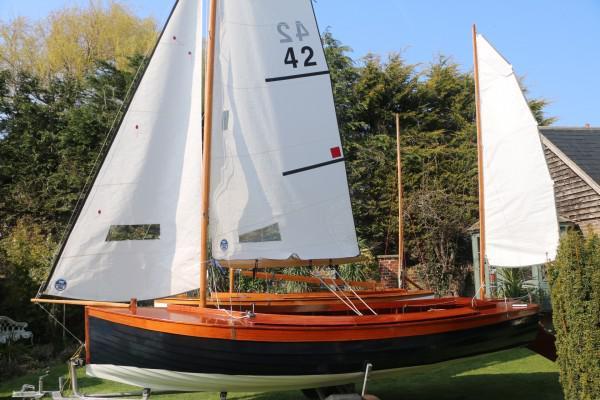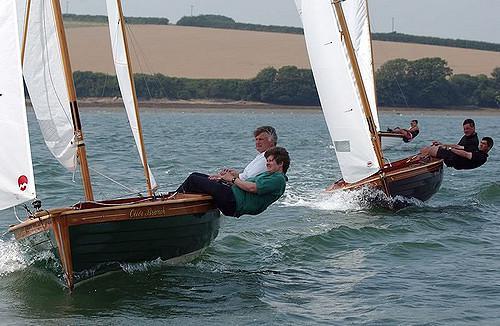The first image is the image on the left, the second image is the image on the right. Examine the images to the left and right. Is the description "in at least one image there is a single boat with 3 raised sails" accurate? Answer yes or no. Yes. 